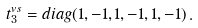Convert formula to latex. <formula><loc_0><loc_0><loc_500><loc_500>\ t _ { 3 } ^ { v s } = d i a g ( 1 , - 1 , 1 , - 1 , 1 , - 1 ) \, .</formula> 